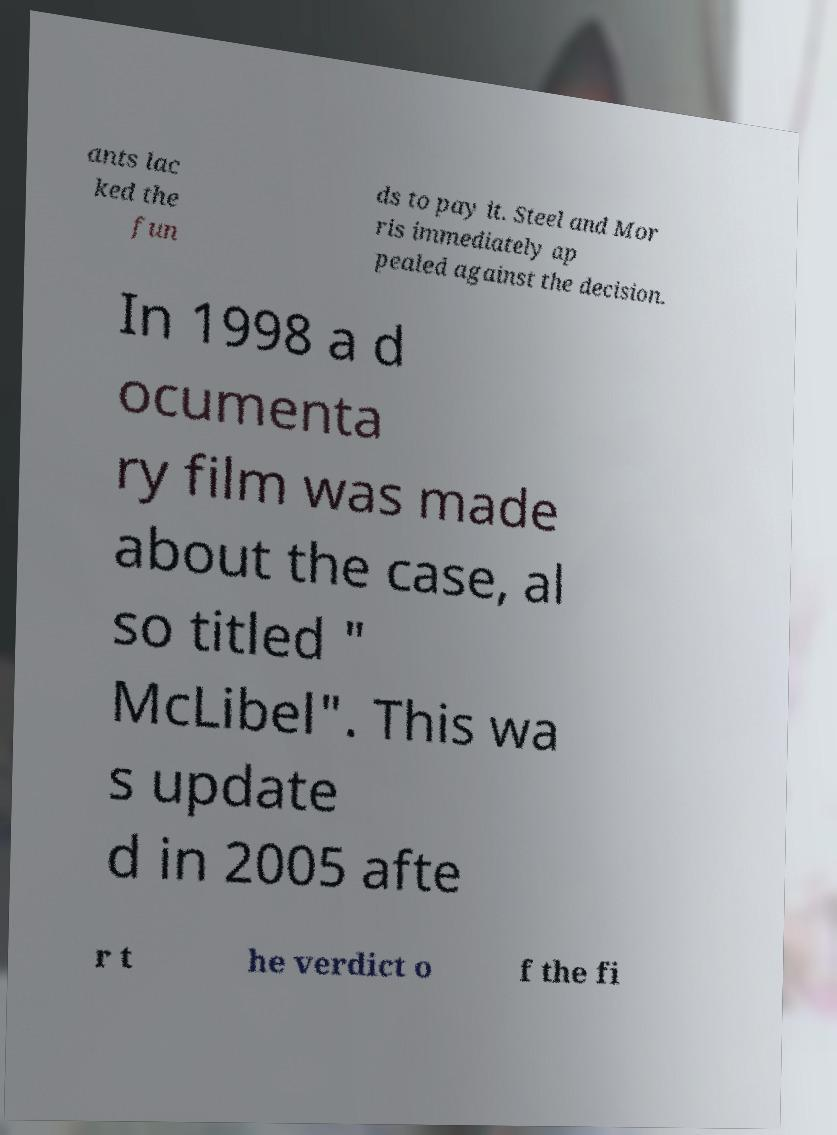Please identify and transcribe the text found in this image. ants lac ked the fun ds to pay it. Steel and Mor ris immediately ap pealed against the decision. In 1998 a d ocumenta ry film was made about the case, al so titled " McLibel". This wa s update d in 2005 afte r t he verdict o f the fi 